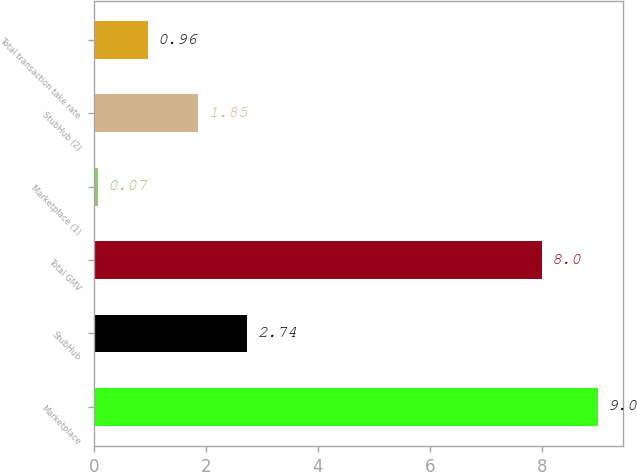Convert chart. <chart><loc_0><loc_0><loc_500><loc_500><bar_chart><fcel>Marketplace<fcel>StubHub<fcel>Total GMV<fcel>Marketplace (1)<fcel>StubHub (2)<fcel>Total transaction take rate<nl><fcel>9<fcel>2.74<fcel>8<fcel>0.07<fcel>1.85<fcel>0.96<nl></chart> 